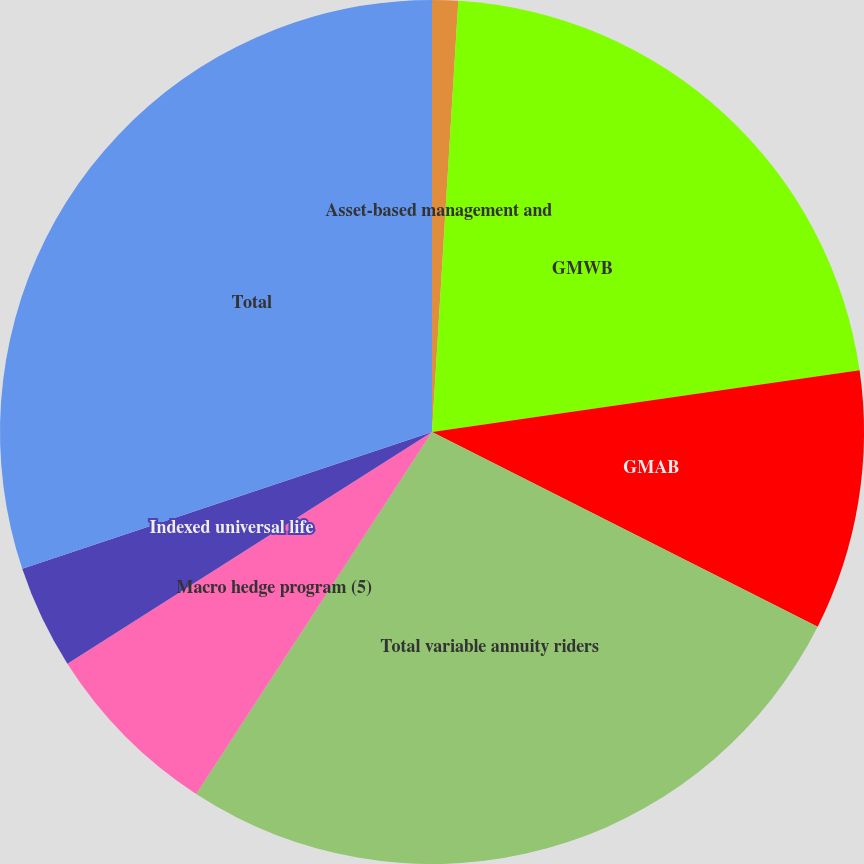<chart> <loc_0><loc_0><loc_500><loc_500><pie_chart><fcel>Asset-based management and<fcel>GMWB<fcel>GMAB<fcel>Total variable annuity riders<fcel>Macro hedge program (5)<fcel>Indexed universal life<fcel>Total<nl><fcel>0.97%<fcel>21.75%<fcel>9.72%<fcel>26.75%<fcel>6.8%<fcel>3.88%<fcel>30.13%<nl></chart> 